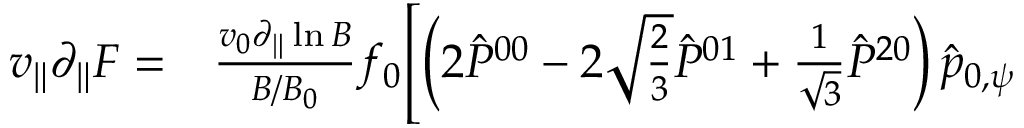Convert formula to latex. <formula><loc_0><loc_0><loc_500><loc_500>\begin{array} { r l } { v _ { \| } \partial _ { \| } F = } & \frac { v _ { 0 } \partial _ { \| } \ln B } { B / B _ { 0 } } f _ { 0 } \Big [ \left ( 2 \hat { P } ^ { 0 0 } - 2 \sqrt { \frac { 2 } { 3 } } \hat { P } ^ { 0 1 } + \frac { 1 } { \sqrt { 3 } } \hat { P } ^ { 2 0 } \right ) \hat { p } _ { 0 , \psi } } \end{array}</formula> 